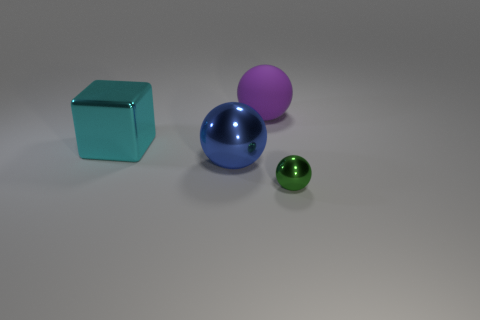Add 2 red cubes. How many objects exist? 6 Subtract all spheres. How many objects are left? 1 Add 3 blocks. How many blocks are left? 4 Add 2 big cyan blocks. How many big cyan blocks exist? 3 Subtract 0 yellow balls. How many objects are left? 4 Subtract all tiny things. Subtract all blocks. How many objects are left? 2 